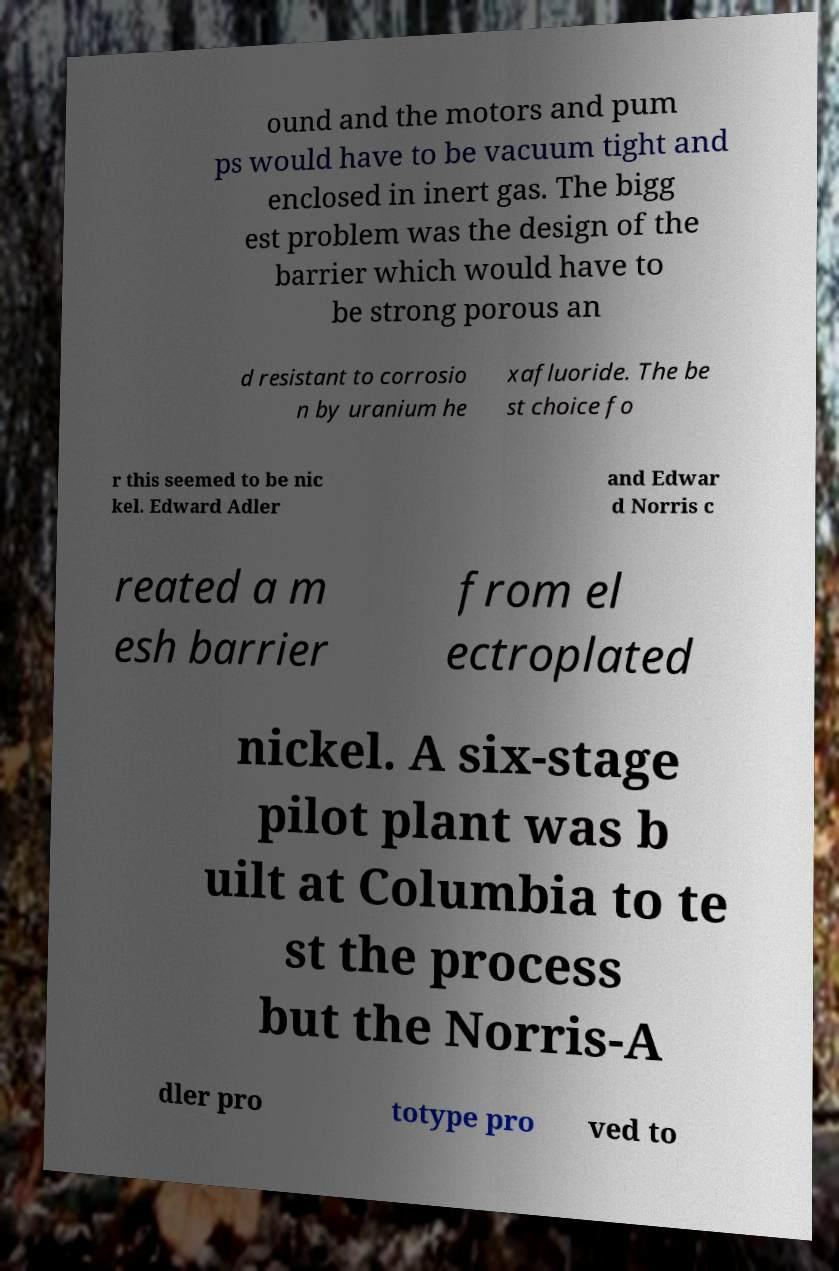Please identify and transcribe the text found in this image. ound and the motors and pum ps would have to be vacuum tight and enclosed in inert gas. The bigg est problem was the design of the barrier which would have to be strong porous an d resistant to corrosio n by uranium he xafluoride. The be st choice fo r this seemed to be nic kel. Edward Adler and Edwar d Norris c reated a m esh barrier from el ectroplated nickel. A six-stage pilot plant was b uilt at Columbia to te st the process but the Norris-A dler pro totype pro ved to 